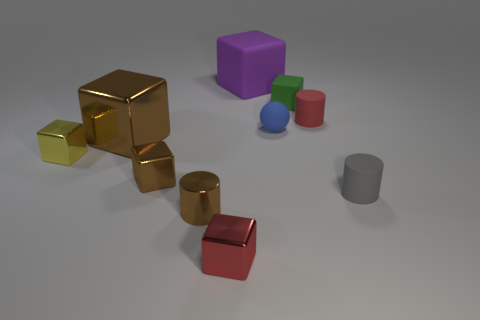What color is the matte thing that is in front of the yellow shiny block? The color of the matte object located in front of the shiny yellow block is a neutral gray, complementing the vivid array of colors present in the rest of the scene. 